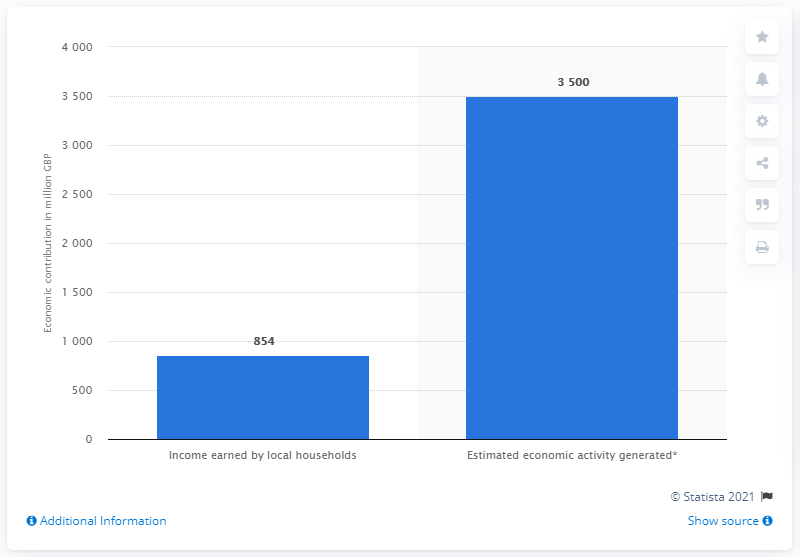Outline some significant characteristics in this image. Airbnb's contribution to the UK economy was valued at £854 million between July 2017 and July 2018. 